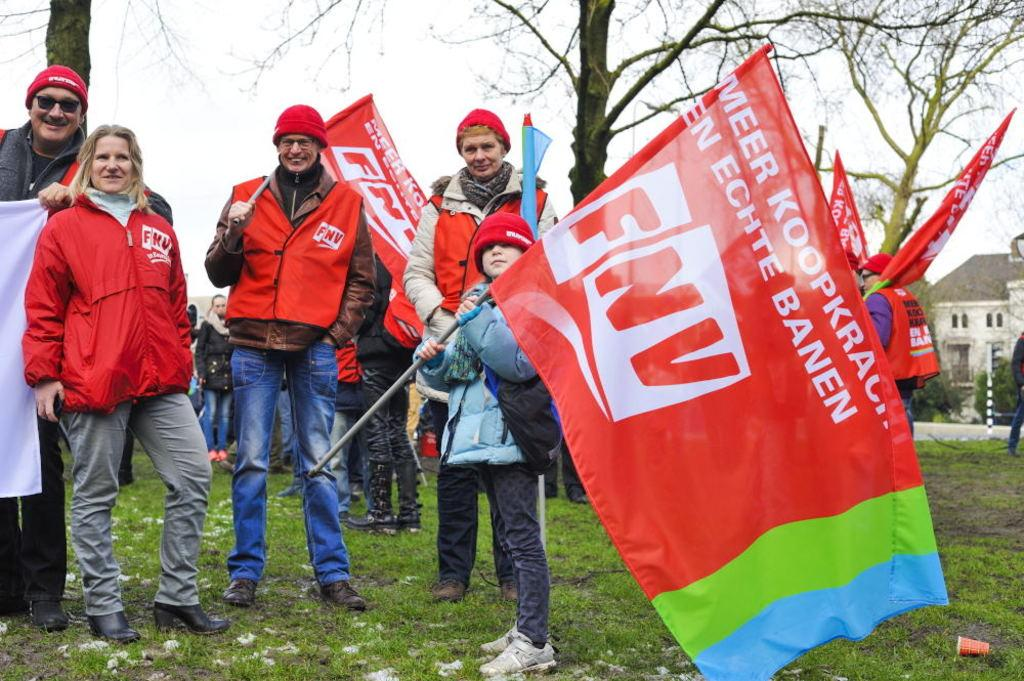What are the people in the image doing? The people in the image are standing. What are some of the people holding? Some of the people are holding flags. What type of vegetation is present in the image? There are trees and grass in the image. What type of structure can be seen in the image? There is a house in the image. What is visible in the background of the image? The sky is visible in the background of the image. How many eyes can be seen on the stone in the image? There is no stone present in the image, and therefore no eyes can be seen on it. 